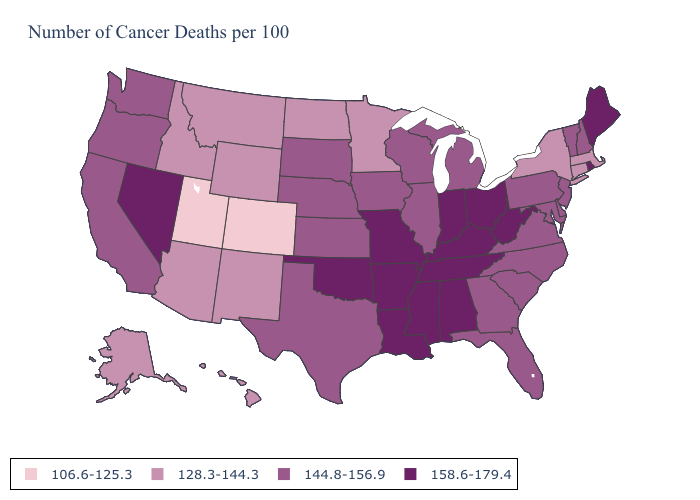Does New Mexico have a lower value than Massachusetts?
Keep it brief. No. What is the value of North Dakota?
Concise answer only. 128.3-144.3. What is the highest value in the USA?
Keep it brief. 158.6-179.4. Does the first symbol in the legend represent the smallest category?
Quick response, please. Yes. What is the highest value in the USA?
Keep it brief. 158.6-179.4. Which states have the lowest value in the USA?
Quick response, please. Colorado, Utah. Does Utah have the lowest value in the USA?
Concise answer only. Yes. What is the lowest value in states that border Minnesota?
Answer briefly. 128.3-144.3. Does Indiana have the highest value in the MidWest?
Keep it brief. Yes. Which states have the lowest value in the MidWest?
Be succinct. Minnesota, North Dakota. What is the value of Hawaii?
Quick response, please. 128.3-144.3. Is the legend a continuous bar?
Give a very brief answer. No. Does Vermont have a higher value than Texas?
Concise answer only. No. Among the states that border Missouri , does Arkansas have the lowest value?
Quick response, please. No. 